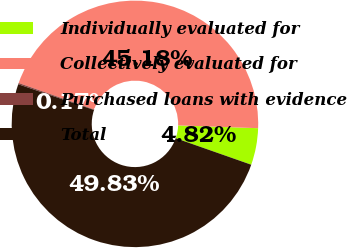<chart> <loc_0><loc_0><loc_500><loc_500><pie_chart><fcel>Individually evaluated for<fcel>Collectively evaluated for<fcel>Purchased loans with evidence<fcel>Total<nl><fcel>4.82%<fcel>45.18%<fcel>0.17%<fcel>49.83%<nl></chart> 